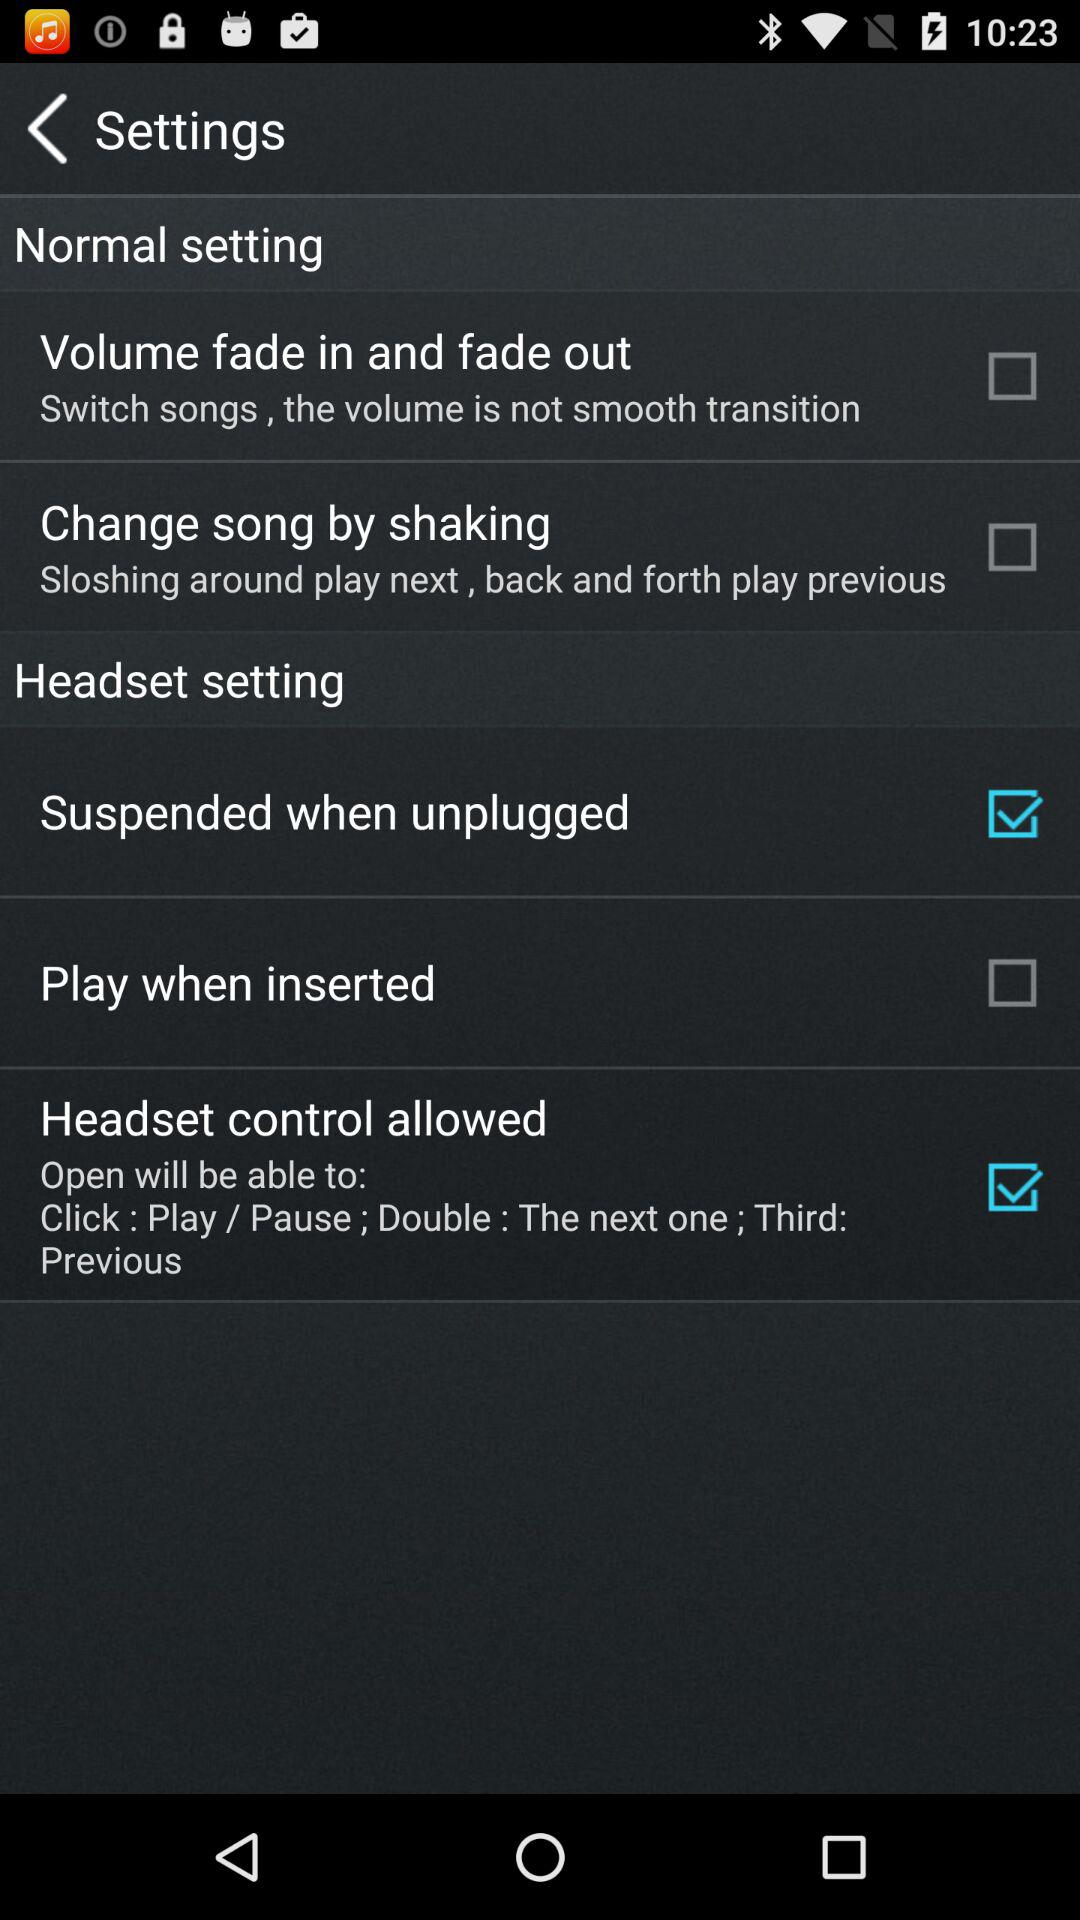How many items are there in the normal settings section?
Answer the question using a single word or phrase. 2 